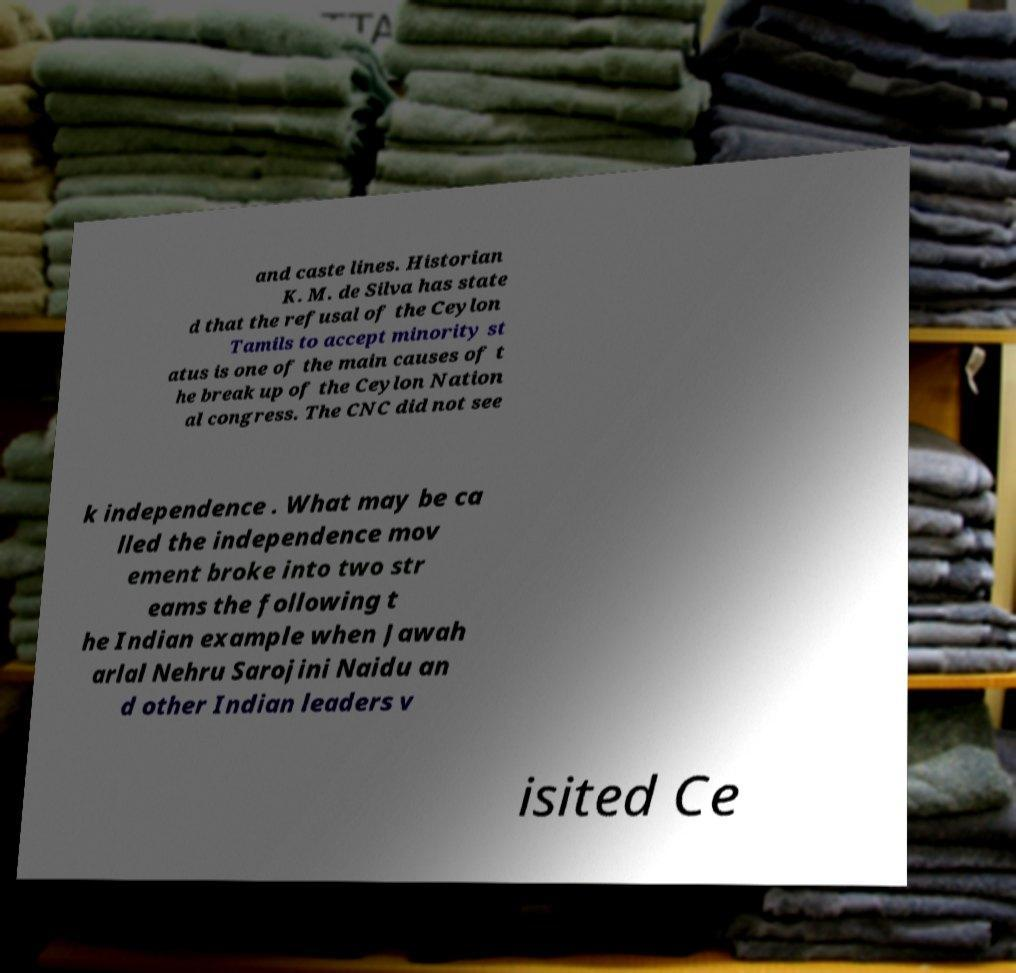I need the written content from this picture converted into text. Can you do that? and caste lines. Historian K. M. de Silva has state d that the refusal of the Ceylon Tamils to accept minority st atus is one of the main causes of t he break up of the Ceylon Nation al congress. The CNC did not see k independence . What may be ca lled the independence mov ement broke into two str eams the following t he Indian example when Jawah arlal Nehru Sarojini Naidu an d other Indian leaders v isited Ce 